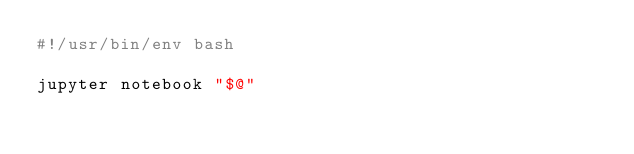<code> <loc_0><loc_0><loc_500><loc_500><_Bash_>#!/usr/bin/env bash

jupyter notebook "$@"
</code> 